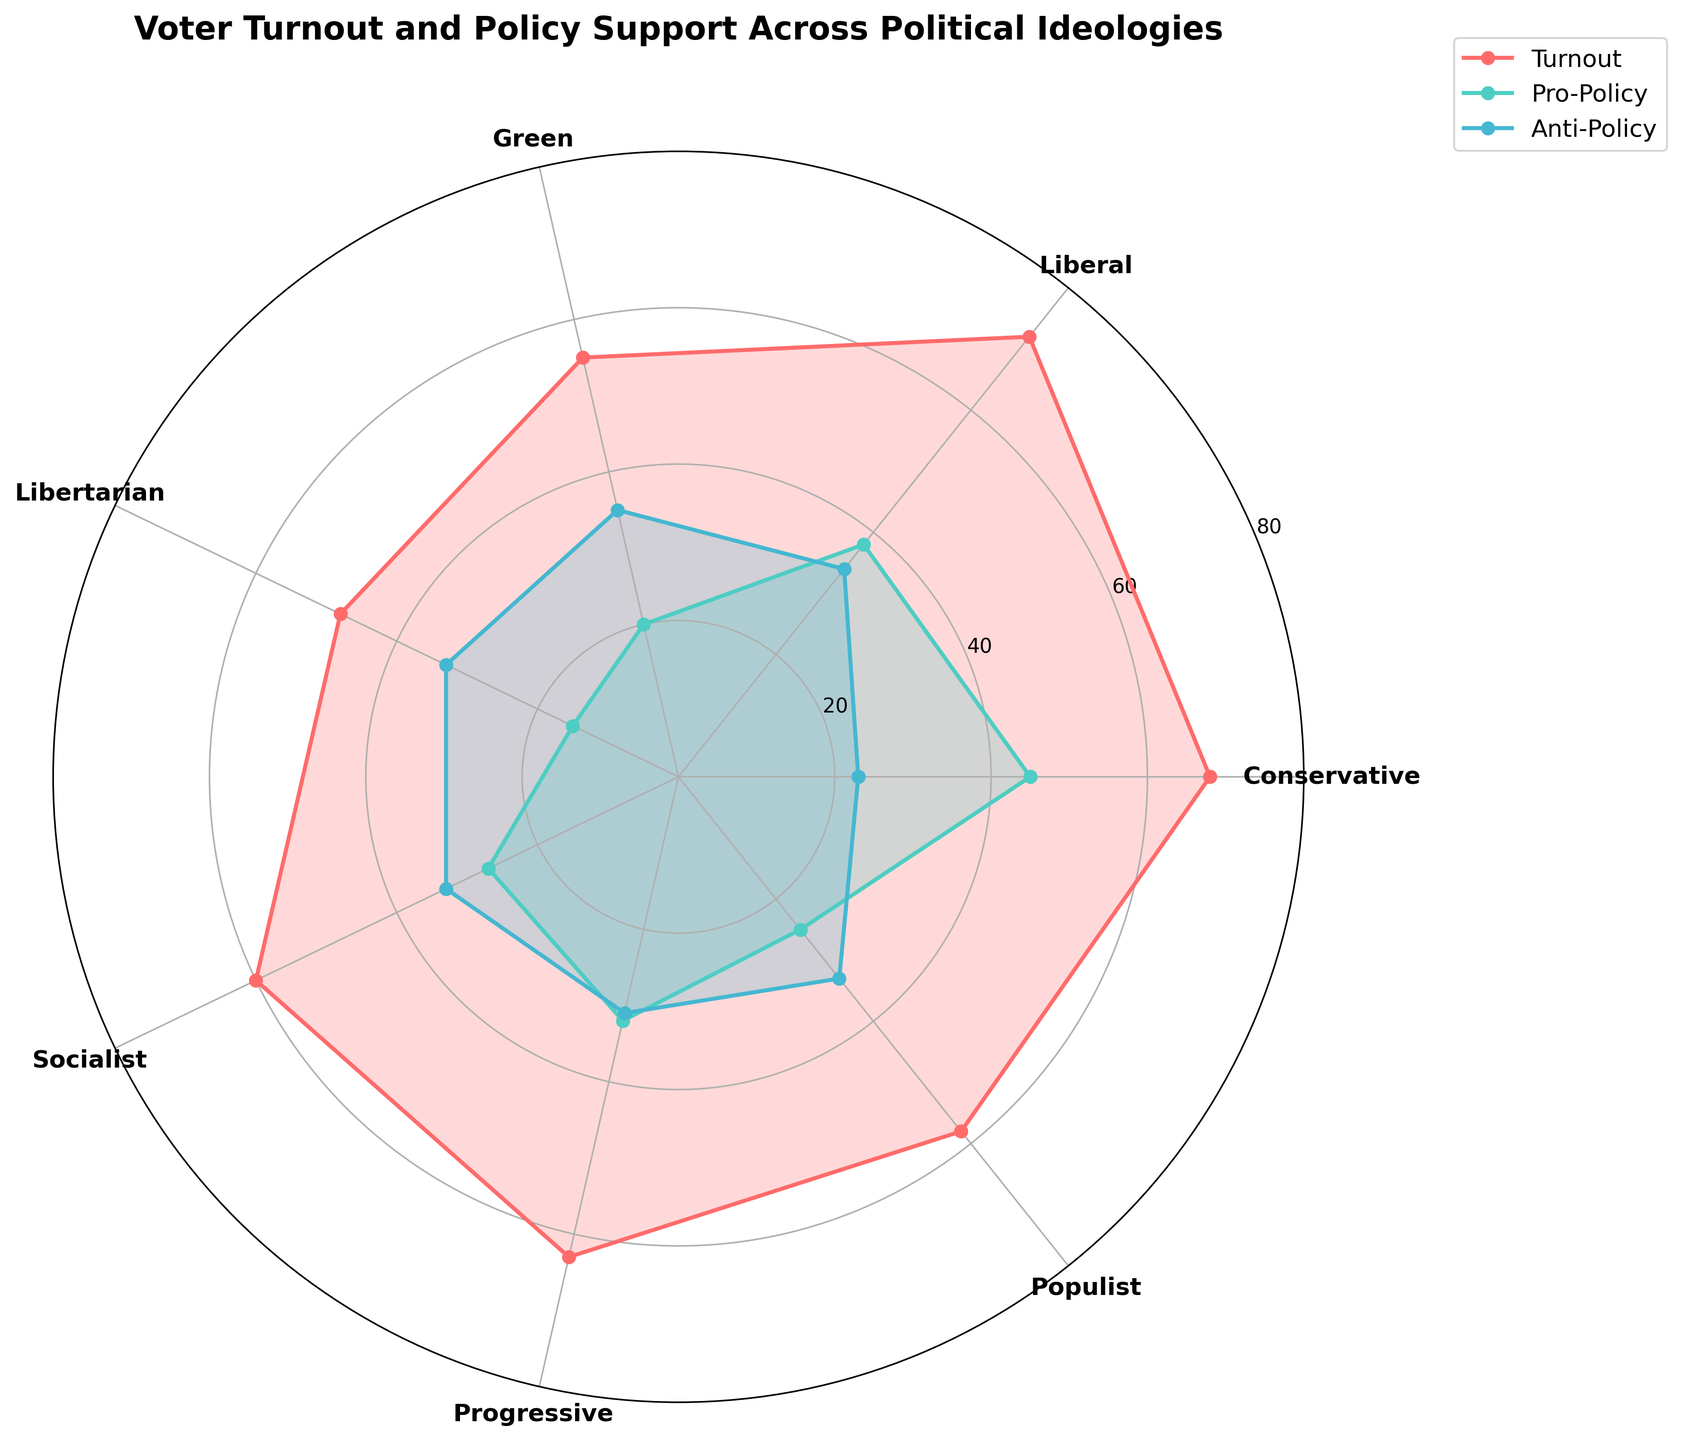What's the title of the figure? The title is usually found at the top of the figure. It summarizes the main topic or focus of the plot.
Answer: Voter Turnout and Policy Support Across Political Ideologies How many political ideologies are represented in the chart? Count the number of distinct political ideology labels around the polar plot.
Answer: 7 Which political ideology has the lowest voter turnout? Check the plot for the lowest point of the turnout line (often marked by a specific color and shape).
Answer: Libertarian What is the voter turnout percentage for the Progressive ideology? Look at the value where the turnout line intersects with the angle corresponding to the Progressive ideology.
Answer: 63 Compare the Pro-Policy support between Conservative and Green ideologies. Which one is higher? Check the values of the Pro-Policy line at the angles corresponding to Conservative and Green ideologies and compare them.
Answer: Conservative What is the sum of the Anti-Policy support across all political ideologies? Add the Anti-Policy support values for each political ideology.
Answer: 222 Which ideology shows the closest Pro-Policy and Anti-Policy values? Check for the ideology where the Pro-Policy and Anti-Policy lines are closest together in value on the plot.
Answer: Socialist How does the voter turnout for the Liberal ideology compare to that for the Populist ideology? Look at the points where the turnout line intersects the angles for both Liberal and Populist ideologies and compare their values.
Answer: Liberal has a higher turnout What is the average voter turnout across all political ideologies? Sum all the voter turnout percentages and divide by the number of ideologies.
Answer: 60.57 Which category (Pro-Policy or Anti-Policy) generally shows more variation across ideologies based on the plot? Examine the spread of values for both the Pro-Policy and Anti-Policy lines and determine which shows greater fluctuation.
Answer: Anti-Policy 